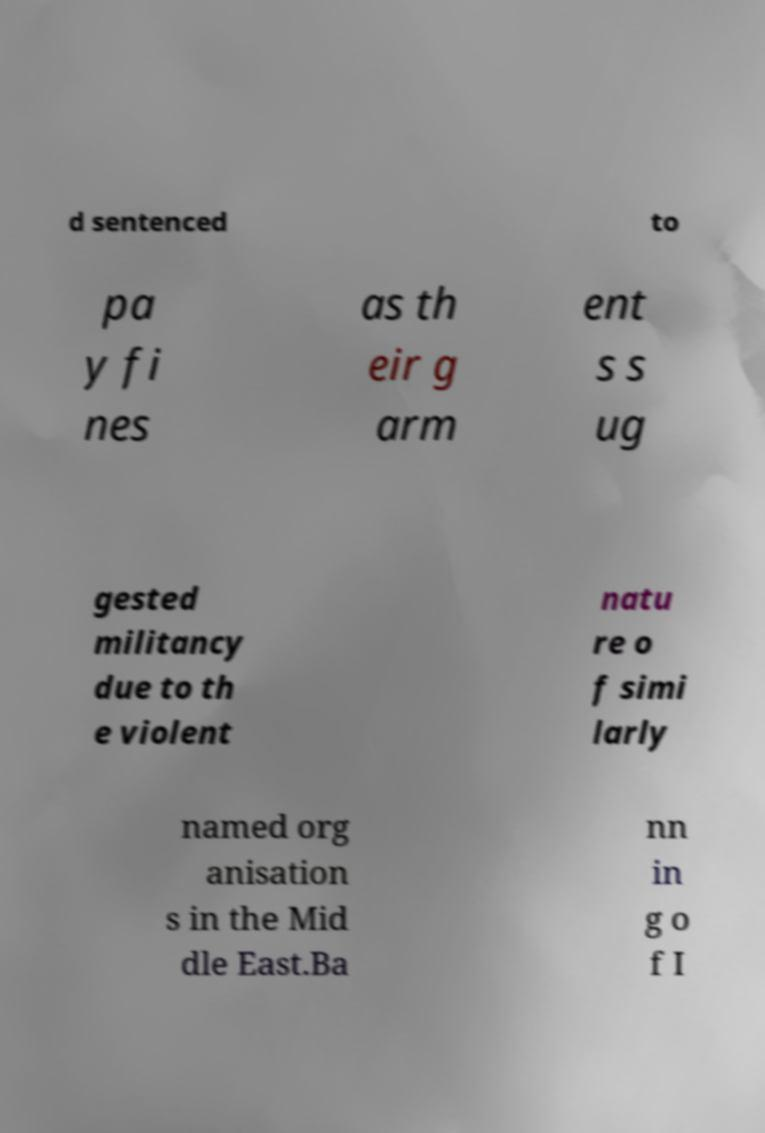Can you read and provide the text displayed in the image?This photo seems to have some interesting text. Can you extract and type it out for me? d sentenced to pa y fi nes as th eir g arm ent s s ug gested militancy due to th e violent natu re o f simi larly named org anisation s in the Mid dle East.Ba nn in g o f I 